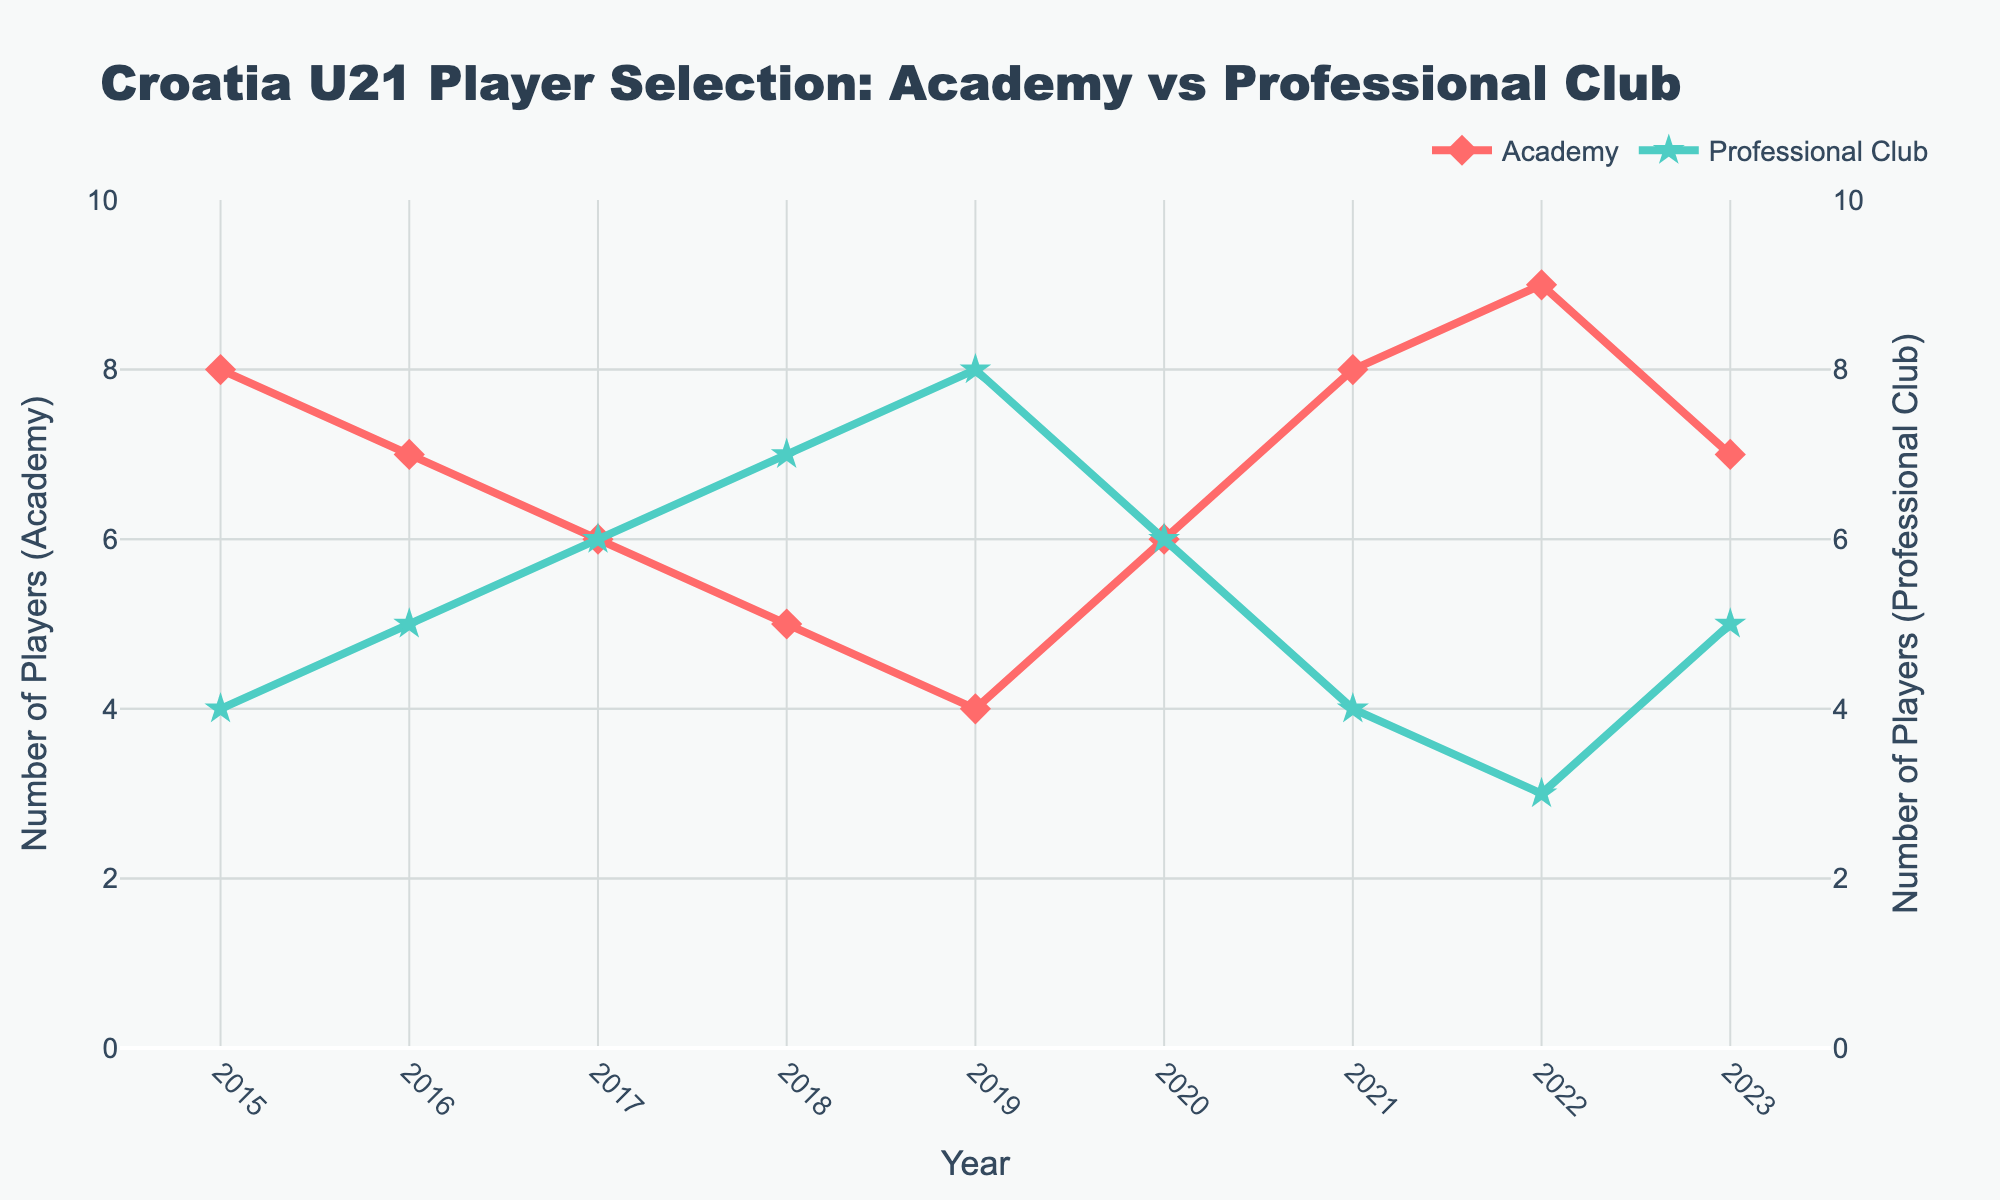What is the color of the line representing the Academy in the figure? The line representing the Academy in the plot is colored in a shade of red.
Answer: Red How many players were selected from professional clubs in 2019? According to the plot, the number of players from professional clubs in 2019 is located where the green line meets the year 2019 on the x-axis. The value at this point is 8.
Answer: 8 What is the overall trend for the number of players selected from academies from 2015 to 2023? The trend can be observed by following the red line from 2015 to 2023. Starting at 8 in 2015, it decreases initially, reaches a low of 4 in 2019, and then increases again to 7 in 2023.
Answer: Decrease then increase Compare the number of players selected from academies and professional clubs in 2022. In 2022, the red line (Academy) is at 9, and the green line (Professional Club) is at 3. Therefore, more players were selected from academies.
Answer: More academies What is the total number of players selected from academies over the years 2015 to 2023? To find the total, sum the values for the Academy for each year from 2015 to 2023: 8+7+6+5+4+6+8+9+7 = 60
Answer: 60 What is the average number of players selected from professional clubs from 2015 to 2023? To find the average, sum the values for the Professional Club for each year from 2015 to 2023 (4+5+6+7+8+6+4+3+5 = 48) and divide by the number of years (9). The average is 48/9 = 5.33.
Answer: 5.33 Which year had the highest number of players selected from academies? The highest point on the red line represents the year with the most academy players. The maximum value is 9, which occurs in 2022.
Answer: 2022 How did the number of professional club players change from 2016 to 2019? The green line from 2016 (5 players) to 2019 (8 players) shows an increase.
Answer: Increase What is the difference in the number of players selected from academies and professional clubs in 2021? In 2021, the red line (Academy) is at 8, and the green line (Professional Club) is at 4. The difference is 8 - 4 = 4.
Answer: 4 Identify the years where the number of players from academies and professional clubs was equal. Checking the plot, the years where the red and green lines intersect are 2017 and 2020, both having 6 players each from academies and professional clubs.
Answer: 2017 and 2020 